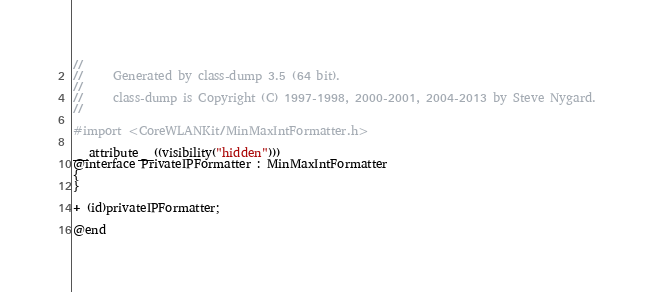Convert code to text. <code><loc_0><loc_0><loc_500><loc_500><_C_>//
//     Generated by class-dump 3.5 (64 bit).
//
//     class-dump is Copyright (C) 1997-1998, 2000-2001, 2004-2013 by Steve Nygard.
//

#import <CoreWLANKit/MinMaxIntFormatter.h>

__attribute__((visibility("hidden")))
@interface PrivateIPFormatter : MinMaxIntFormatter
{
}

+ (id)privateIPFormatter;

@end

</code> 